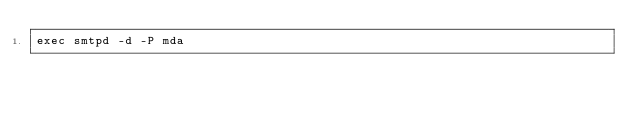<code> <loc_0><loc_0><loc_500><loc_500><_Bash_>exec smtpd -d -P mda
</code> 